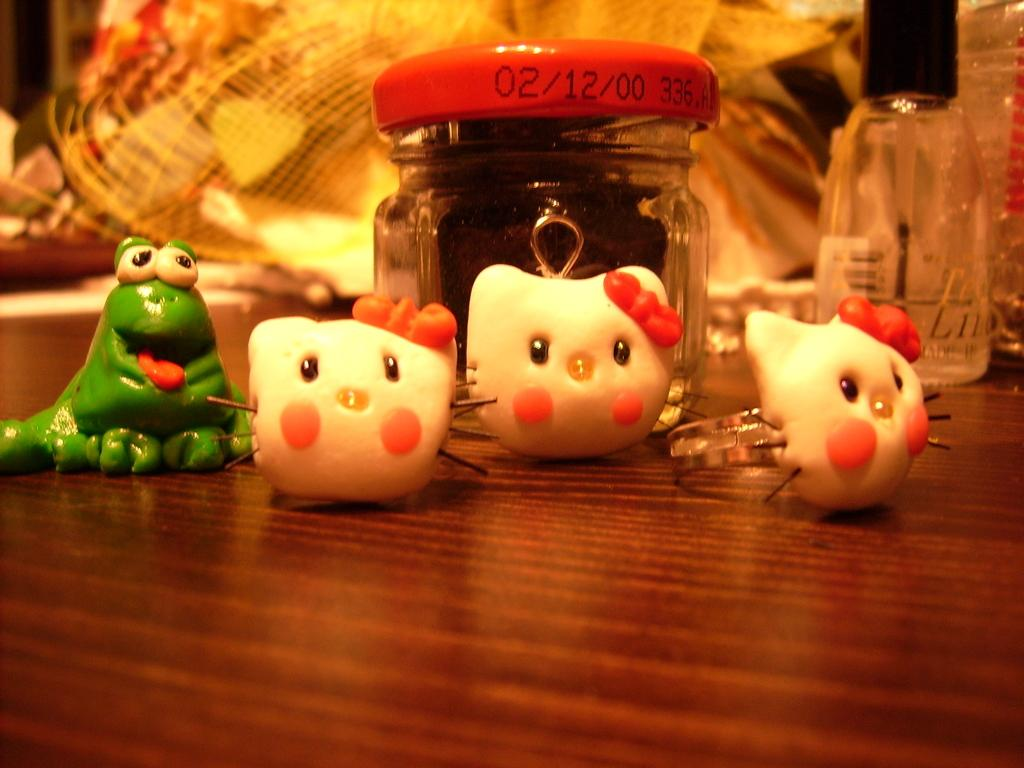What type of container is visible in the image? There is a glass bottle in the image. What else can be seen in the image besides the glass bottle? There are toys and other objects on a wooden surface in the image. Can you describe the background of the image? The background of the image is blurred. What type of silk material is draped over the zebra in the image? There is no silk material or zebra present in the image. How many boys are visible in the image? There are no boys present in the image. 